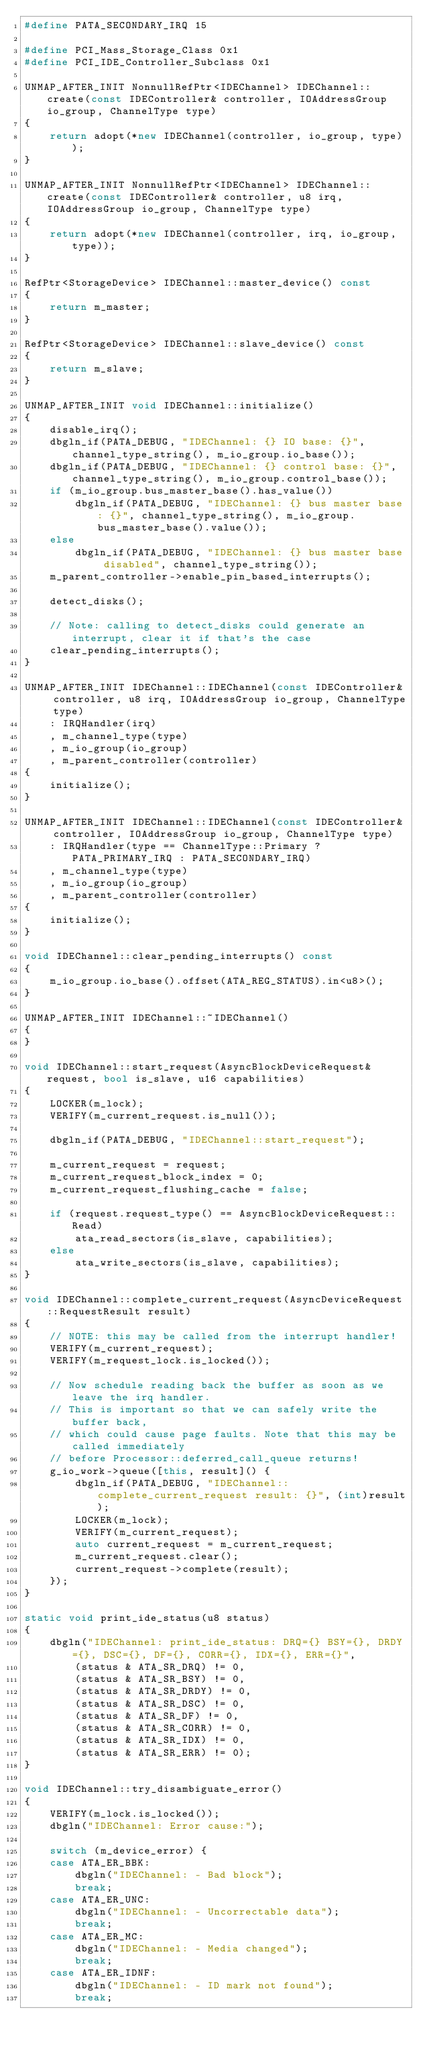<code> <loc_0><loc_0><loc_500><loc_500><_C++_>#define PATA_SECONDARY_IRQ 15

#define PCI_Mass_Storage_Class 0x1
#define PCI_IDE_Controller_Subclass 0x1

UNMAP_AFTER_INIT NonnullRefPtr<IDEChannel> IDEChannel::create(const IDEController& controller, IOAddressGroup io_group, ChannelType type)
{
    return adopt(*new IDEChannel(controller, io_group, type));
}

UNMAP_AFTER_INIT NonnullRefPtr<IDEChannel> IDEChannel::create(const IDEController& controller, u8 irq, IOAddressGroup io_group, ChannelType type)
{
    return adopt(*new IDEChannel(controller, irq, io_group, type));
}

RefPtr<StorageDevice> IDEChannel::master_device() const
{
    return m_master;
}

RefPtr<StorageDevice> IDEChannel::slave_device() const
{
    return m_slave;
}

UNMAP_AFTER_INIT void IDEChannel::initialize()
{
    disable_irq();
    dbgln_if(PATA_DEBUG, "IDEChannel: {} IO base: {}", channel_type_string(), m_io_group.io_base());
    dbgln_if(PATA_DEBUG, "IDEChannel: {} control base: {}", channel_type_string(), m_io_group.control_base());
    if (m_io_group.bus_master_base().has_value())
        dbgln_if(PATA_DEBUG, "IDEChannel: {} bus master base: {}", channel_type_string(), m_io_group.bus_master_base().value());
    else
        dbgln_if(PATA_DEBUG, "IDEChannel: {} bus master base disabled", channel_type_string());
    m_parent_controller->enable_pin_based_interrupts();

    detect_disks();

    // Note: calling to detect_disks could generate an interrupt, clear it if that's the case
    clear_pending_interrupts();
}

UNMAP_AFTER_INIT IDEChannel::IDEChannel(const IDEController& controller, u8 irq, IOAddressGroup io_group, ChannelType type)
    : IRQHandler(irq)
    , m_channel_type(type)
    , m_io_group(io_group)
    , m_parent_controller(controller)
{
    initialize();
}

UNMAP_AFTER_INIT IDEChannel::IDEChannel(const IDEController& controller, IOAddressGroup io_group, ChannelType type)
    : IRQHandler(type == ChannelType::Primary ? PATA_PRIMARY_IRQ : PATA_SECONDARY_IRQ)
    , m_channel_type(type)
    , m_io_group(io_group)
    , m_parent_controller(controller)
{
    initialize();
}

void IDEChannel::clear_pending_interrupts() const
{
    m_io_group.io_base().offset(ATA_REG_STATUS).in<u8>();
}

UNMAP_AFTER_INIT IDEChannel::~IDEChannel()
{
}

void IDEChannel::start_request(AsyncBlockDeviceRequest& request, bool is_slave, u16 capabilities)
{
    LOCKER(m_lock);
    VERIFY(m_current_request.is_null());

    dbgln_if(PATA_DEBUG, "IDEChannel::start_request");

    m_current_request = request;
    m_current_request_block_index = 0;
    m_current_request_flushing_cache = false;

    if (request.request_type() == AsyncBlockDeviceRequest::Read)
        ata_read_sectors(is_slave, capabilities);
    else
        ata_write_sectors(is_slave, capabilities);
}

void IDEChannel::complete_current_request(AsyncDeviceRequest::RequestResult result)
{
    // NOTE: this may be called from the interrupt handler!
    VERIFY(m_current_request);
    VERIFY(m_request_lock.is_locked());

    // Now schedule reading back the buffer as soon as we leave the irq handler.
    // This is important so that we can safely write the buffer back,
    // which could cause page faults. Note that this may be called immediately
    // before Processor::deferred_call_queue returns!
    g_io_work->queue([this, result]() {
        dbgln_if(PATA_DEBUG, "IDEChannel::complete_current_request result: {}", (int)result);
        LOCKER(m_lock);
        VERIFY(m_current_request);
        auto current_request = m_current_request;
        m_current_request.clear();
        current_request->complete(result);
    });
}

static void print_ide_status(u8 status)
{
    dbgln("IDEChannel: print_ide_status: DRQ={} BSY={}, DRDY={}, DSC={}, DF={}, CORR={}, IDX={}, ERR={}",
        (status & ATA_SR_DRQ) != 0,
        (status & ATA_SR_BSY) != 0,
        (status & ATA_SR_DRDY) != 0,
        (status & ATA_SR_DSC) != 0,
        (status & ATA_SR_DF) != 0,
        (status & ATA_SR_CORR) != 0,
        (status & ATA_SR_IDX) != 0,
        (status & ATA_SR_ERR) != 0);
}

void IDEChannel::try_disambiguate_error()
{
    VERIFY(m_lock.is_locked());
    dbgln("IDEChannel: Error cause:");

    switch (m_device_error) {
    case ATA_ER_BBK:
        dbgln("IDEChannel: - Bad block");
        break;
    case ATA_ER_UNC:
        dbgln("IDEChannel: - Uncorrectable data");
        break;
    case ATA_ER_MC:
        dbgln("IDEChannel: - Media changed");
        break;
    case ATA_ER_IDNF:
        dbgln("IDEChannel: - ID mark not found");
        break;</code> 